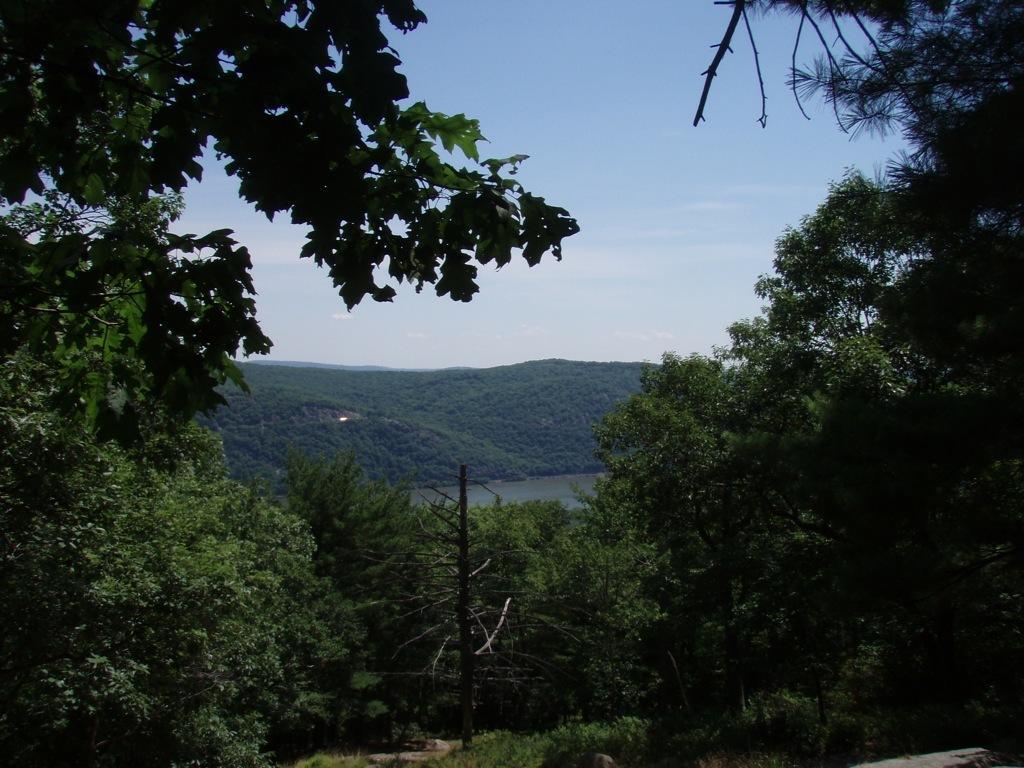Please provide a concise description of this image. In this picture we can see trees and we can see sky in the background. 